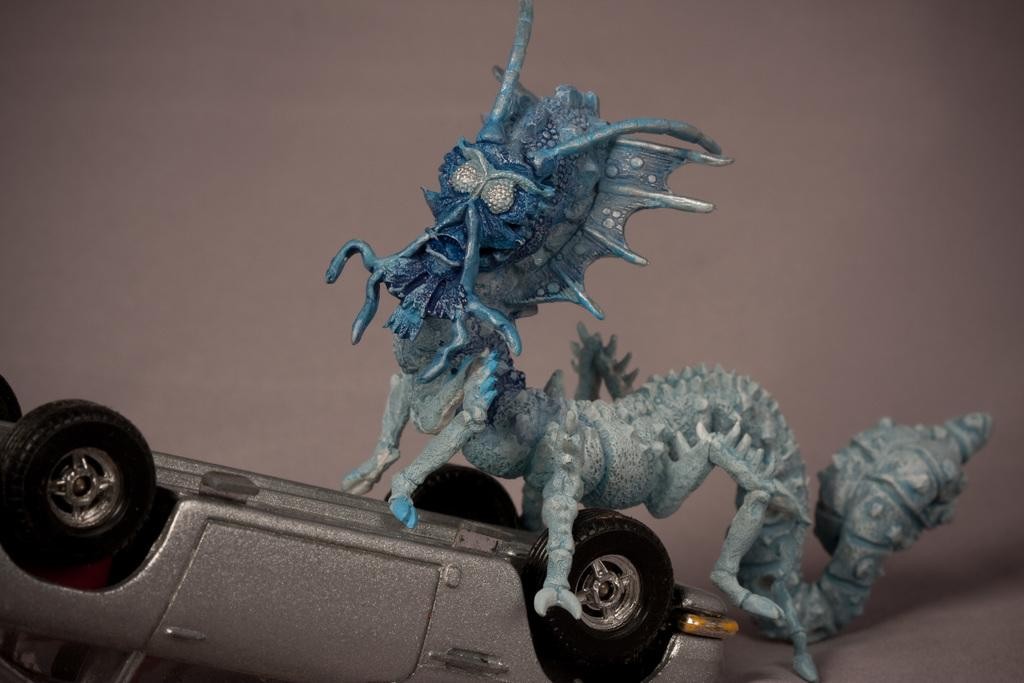What is the main object in the image? There is a toy car in the image. How is the toy car positioned? The toy car is in the reverse direction. What is on top of the toy car? There is an idol on the toy car. What features does the idol have? The idol has legs and hands. What does the idol resemble? The idol resembles an animal. Can you find the receipt for the toy car in the image? There is no receipt present in the image. What type of cherry is placed on the idol's head in the image? There is no cherry present in the image, and the idol does not have any objects on its head. 